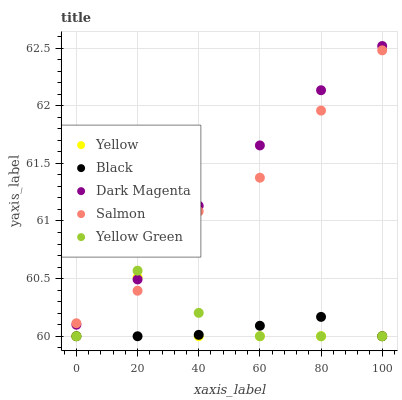Does Black have the minimum area under the curve?
Answer yes or no. Yes. Does Dark Magenta have the maximum area under the curve?
Answer yes or no. Yes. Does Dark Magenta have the minimum area under the curve?
Answer yes or no. No. Does Black have the maximum area under the curve?
Answer yes or no. No. Is Black the smoothest?
Answer yes or no. Yes. Is Yellow the roughest?
Answer yes or no. Yes. Is Dark Magenta the smoothest?
Answer yes or no. No. Is Dark Magenta the roughest?
Answer yes or no. No. Does Black have the lowest value?
Answer yes or no. Yes. Does Dark Magenta have the lowest value?
Answer yes or no. No. Does Dark Magenta have the highest value?
Answer yes or no. Yes. Does Black have the highest value?
Answer yes or no. No. Is Black less than Dark Magenta?
Answer yes or no. Yes. Is Dark Magenta greater than Black?
Answer yes or no. Yes. Does Yellow Green intersect Salmon?
Answer yes or no. Yes. Is Yellow Green less than Salmon?
Answer yes or no. No. Is Yellow Green greater than Salmon?
Answer yes or no. No. Does Black intersect Dark Magenta?
Answer yes or no. No. 